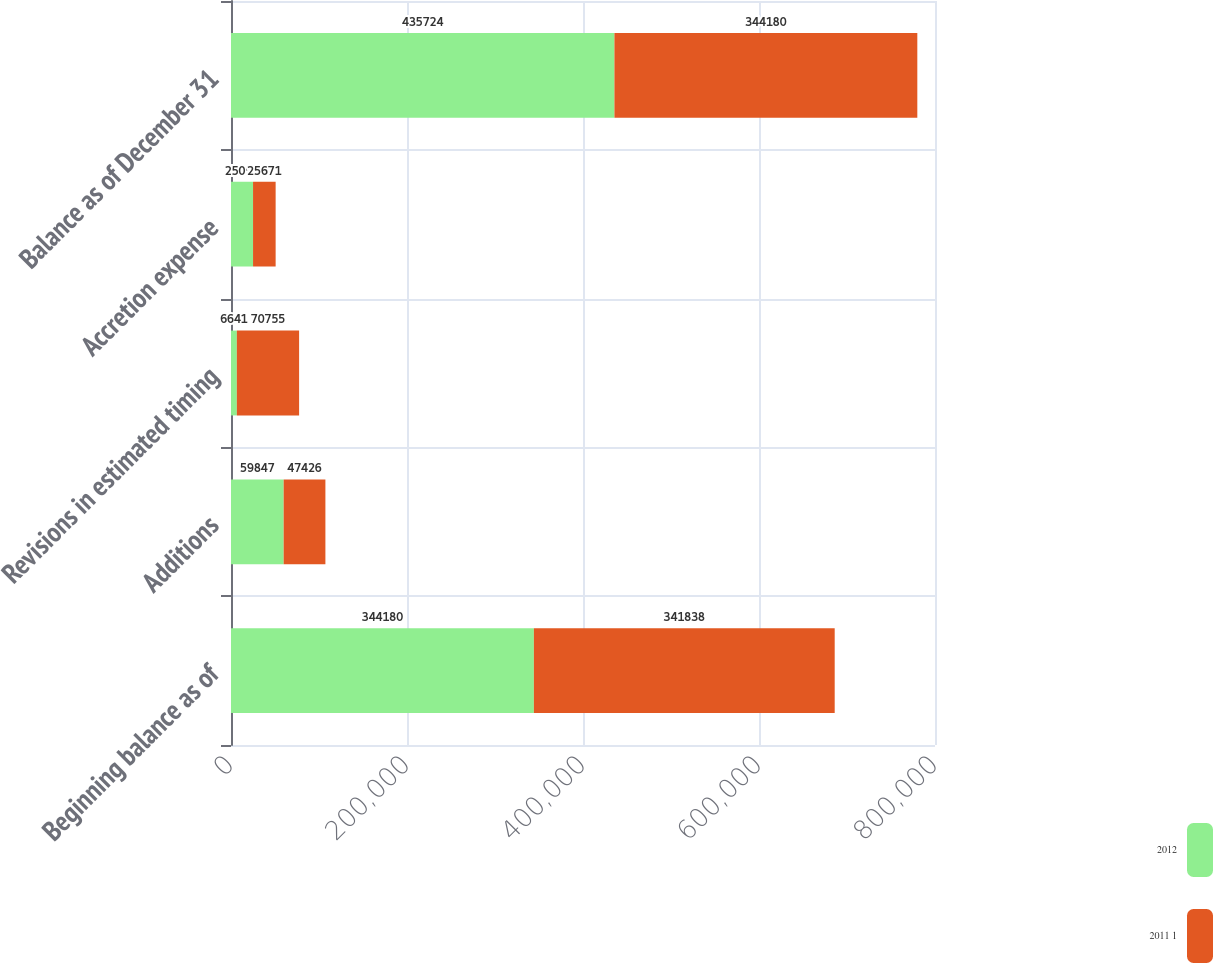Convert chart to OTSL. <chart><loc_0><loc_0><loc_500><loc_500><stacked_bar_chart><ecel><fcel>Beginning balance as of<fcel>Additions<fcel>Revisions in estimated timing<fcel>Accretion expense<fcel>Balance as of December 31<nl><fcel>2012<fcel>344180<fcel>59847<fcel>6641<fcel>25056<fcel>435724<nl><fcel>2011 1<fcel>341838<fcel>47426<fcel>70755<fcel>25671<fcel>344180<nl></chart> 